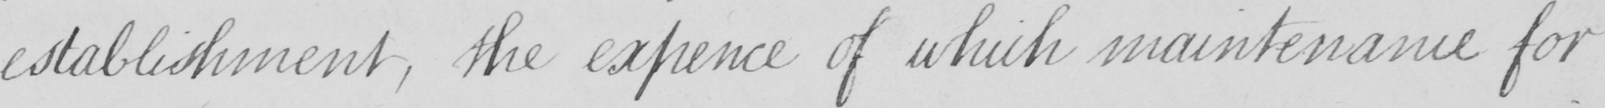What does this handwritten line say? establishment , the expence of which maintenance for 